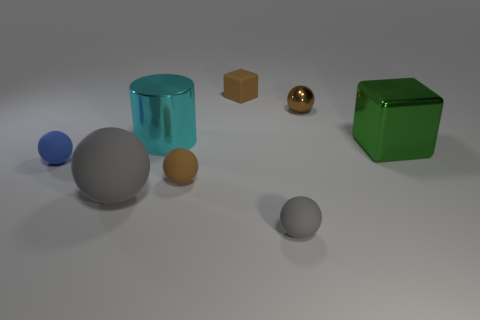Subtract 2 balls. How many balls are left? 3 Subtract all blue spheres. How many spheres are left? 4 Subtract all big spheres. How many spheres are left? 4 Subtract all green balls. Subtract all yellow cylinders. How many balls are left? 5 Add 1 tiny cubes. How many objects exist? 9 Subtract all cylinders. How many objects are left? 7 Subtract 0 yellow cylinders. How many objects are left? 8 Subtract all green metallic objects. Subtract all small brown things. How many objects are left? 4 Add 2 brown objects. How many brown objects are left? 5 Add 7 small purple rubber spheres. How many small purple rubber spheres exist? 7 